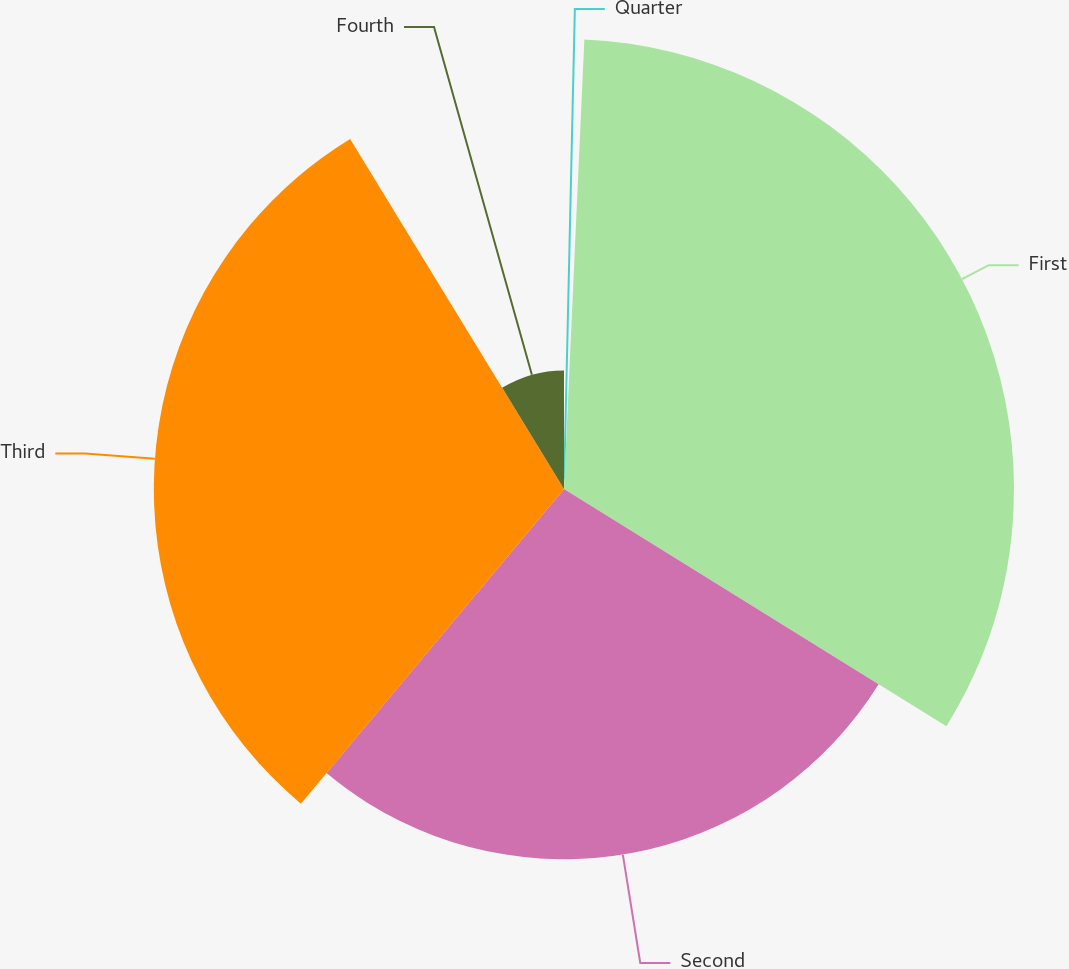Convert chart. <chart><loc_0><loc_0><loc_500><loc_500><pie_chart><fcel>Quarter<fcel>First<fcel>Second<fcel>Third<fcel>Fourth<nl><fcel>0.72%<fcel>33.12%<fcel>27.25%<fcel>30.19%<fcel>8.73%<nl></chart> 